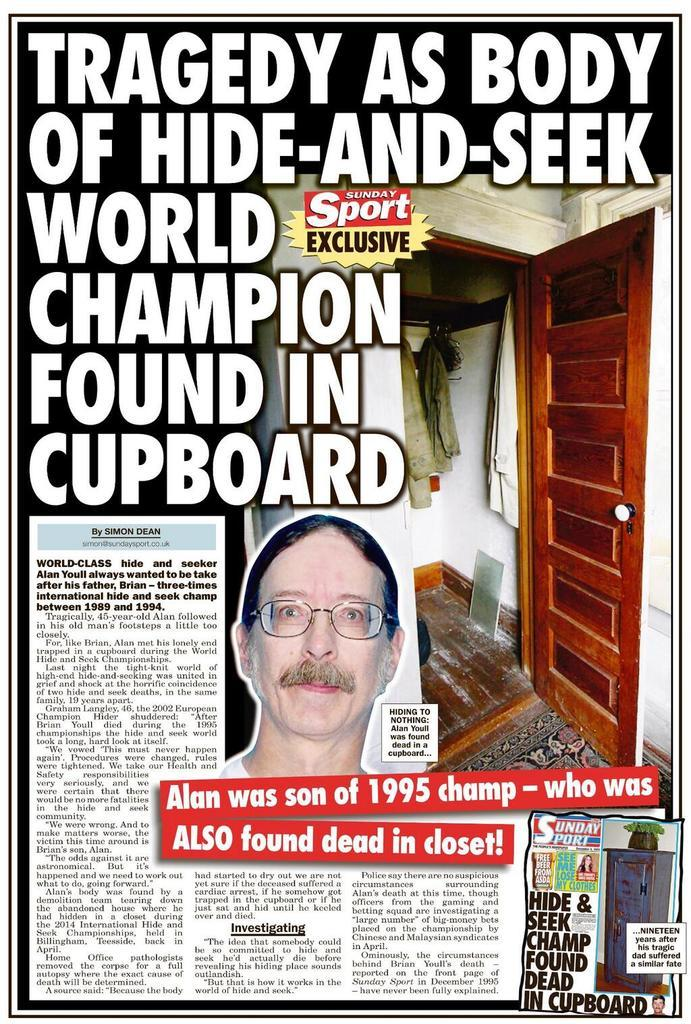What can be read on the poster in the image? There is something written on the poster. What type of object is depicted on the poster? There is a door depicted on the poster. What else is featured on the poster besides the door? Clothes are visible on the poster. Is there any representation of a person on the poster? Yes, there is a picture of a person on the poster. Can you see a bee buzzing around the person's face on the poster? There is no bee or face present on the poster; it only features a picture of a person with a door and clothes. 